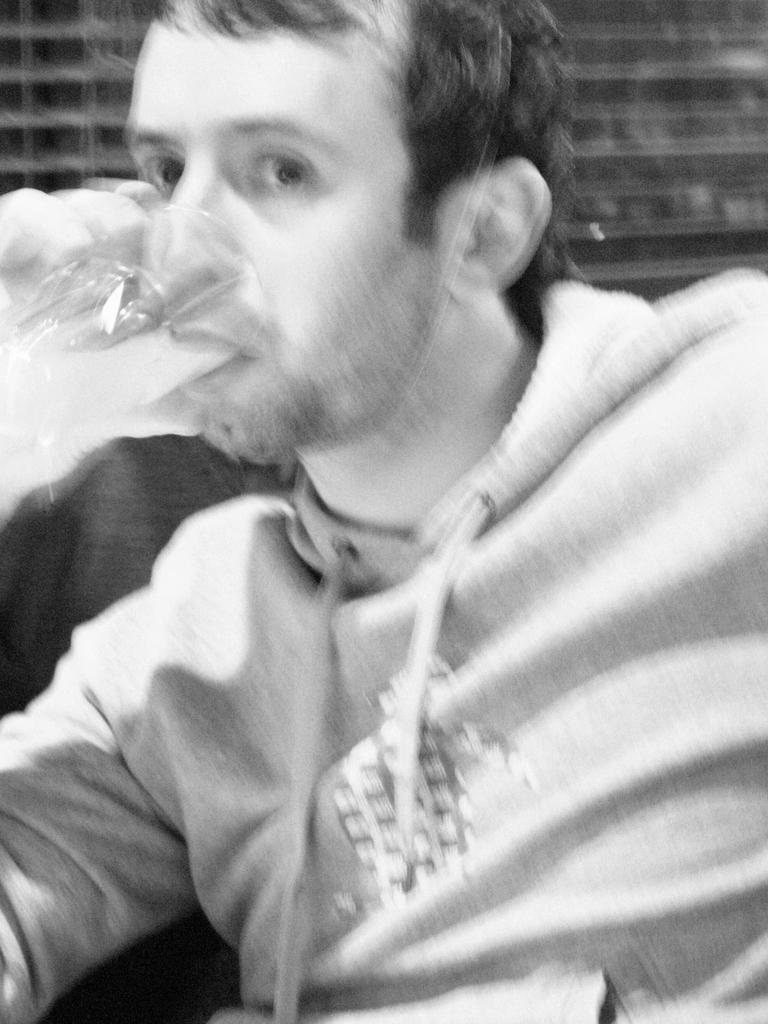What is the color scheme of the image? The image is black and white. Who is present in the image? There is a man in the image. What is the man wearing? The man is wearing a jacket. What is the man holding in the image? The man is holding a glass. What is the man doing with the glass? The man is drinking from the glass. What type of lace can be seen on the plate in the image? There is no plate or lace present in the image; it features a man holding a glass. 